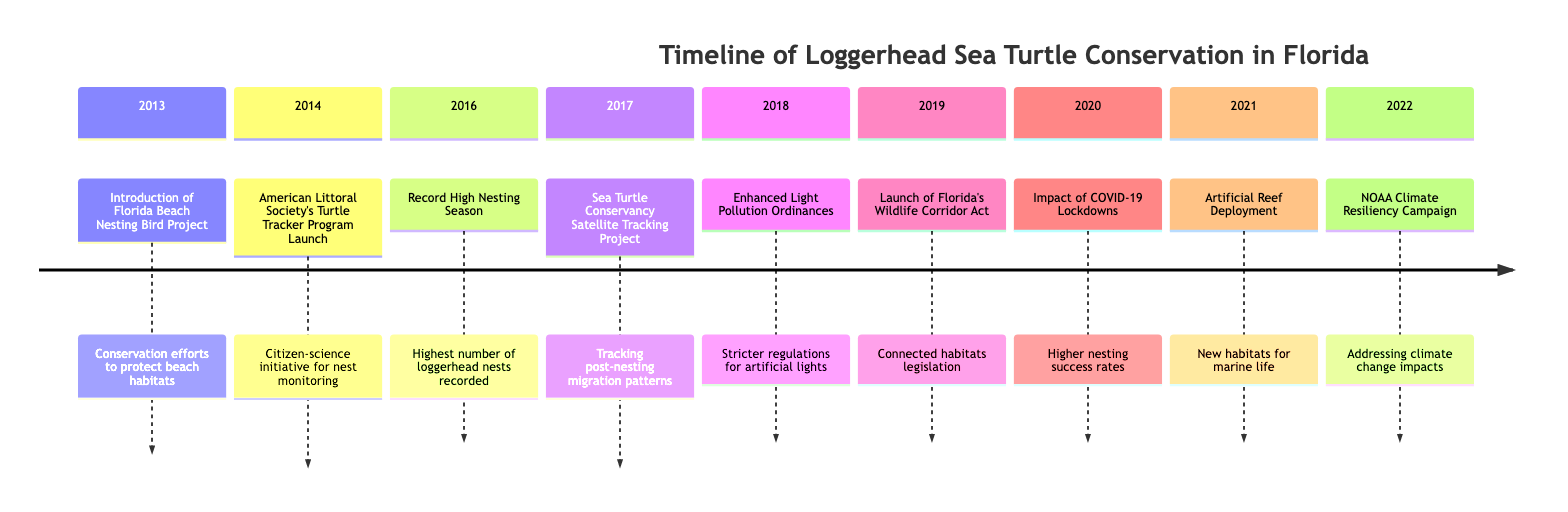What was introduced in 2013? The diagram indicates that in 2013, the "Florida Beach Nesting Bird Project" was introduced, aimed at protecting beach habitats crucial for nesting.
Answer: Florida Beach Nesting Bird Project What event occurred in 2016? According to the timeline, the "Record High Nesting Season" event took place in 2016, marking the highest number of loggerhead nests recorded.
Answer: Record High Nesting Season How many years have events related to loggerhead conservation been recorded in this timeline? The timeline spans from 2013 to 2022, indicating a total of 10 years of recorded events pertaining to loggerhead conservation.
Answer: 10 years Which program was launched in 2014? The diagram details that the "American Littoral Society's Turtle Tracker Program" was launched in 2014, serving as a citizen-science initiative to monitor and protect loggerhead nests.
Answer: American Littoral Society's Turtle Tracker Program What was the impact of COVID-19 lockdowns in 2020? The timeline states that in 2020, the "Impact of COVID-19 Lockdowns" led to reduced human activities on beaches, which resulted in higher nesting success rates for loggerheads.
Answer: Higher nesting success rates Which year's event focused on climate change? In the timeline, it is noted that the "NOAA Climate Resiliency Campaign" in 2022 specifically addressed climate change impacts on sea turtle nesting habitats.
Answer: 2022 What type of initiative was launched in 2017? The diagram indicates that in 2017, the "Sea Turtle Conservancy Satellite Tracking Project" was implemented, which functions as a tracking initiative for post-nesting migration patterns of loggerheads.
Answer: Tracking initiative What legislative act was launched in 2019? The timeline specifies that the "Launch of Florida's Wildlife Corridor Act" occurred in 2019, aiming to create connected habitats for wildlife, benefiting sea turtles.
Answer: Florida's Wildlife Corridor Act What measure was taken in 2018 regarding light pollution? The diagram shows that in 2018, "Enhanced Light Pollution Ordinances" were put in place, which implemented stricter regulations to curb disorienting artificial lights near nesting sites.
Answer: Enhanced Light Pollution Ordinances 